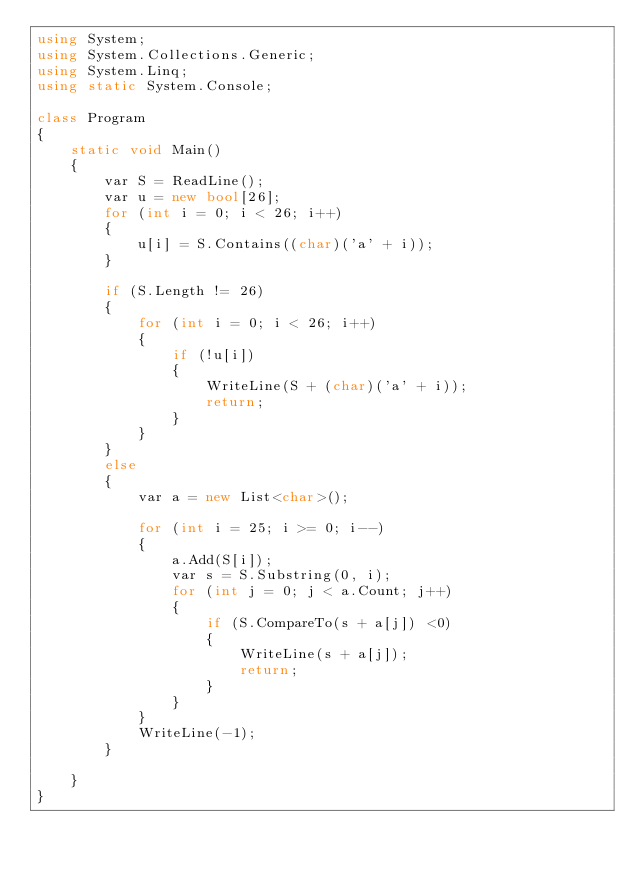<code> <loc_0><loc_0><loc_500><loc_500><_C#_>using System;
using System.Collections.Generic;
using System.Linq;
using static System.Console;

class Program
{
    static void Main()
    {
        var S = ReadLine();
        var u = new bool[26];
        for (int i = 0; i < 26; i++)
        {
            u[i] = S.Contains((char)('a' + i));
        }

        if (S.Length != 26)
        {
            for (int i = 0; i < 26; i++)
            {
                if (!u[i])
                {
                    WriteLine(S + (char)('a' + i));
                    return;
                }
            }
        }
        else
        {
            var a = new List<char>();
            
            for (int i = 25; i >= 0; i--)
            {
                a.Add(S[i]);
                var s = S.Substring(0, i);
                for (int j = 0; j < a.Count; j++)
                {
                    if (S.CompareTo(s + a[j]) <0)
                    {
                        WriteLine(s + a[j]);
                        return;
                    }
                }
            }
            WriteLine(-1);
        }

    }
}</code> 